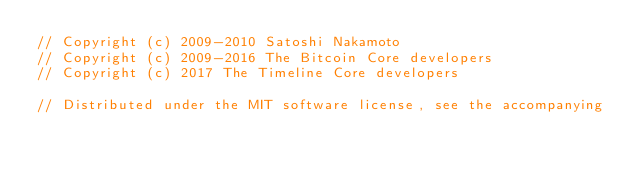<code> <loc_0><loc_0><loc_500><loc_500><_C_>// Copyright (c) 2009-2010 Satoshi Nakamoto
// Copyright (c) 2009-2016 The Bitcoin Core developers
// Copyright (c) 2017 The Timeline Core developers

// Distributed under the MIT software license, see the accompanying</code> 